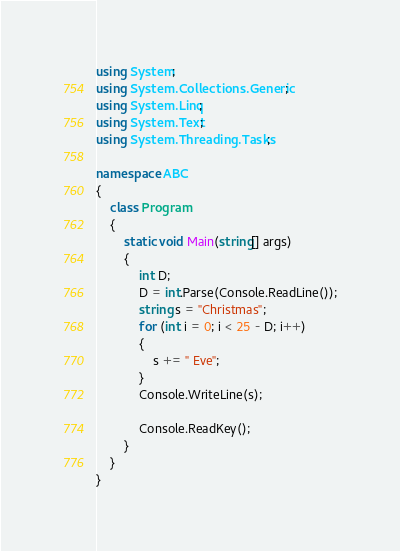<code> <loc_0><loc_0><loc_500><loc_500><_C#_>using System;
using System.Collections.Generic;
using System.Linq;
using System.Text;
using System.Threading.Tasks;

namespace ABC
{
	class Program
	{
		static void Main(string[] args)
		{
			int D;
			D = int.Parse(Console.ReadLine());
			string s = "Christmas";
			for (int i = 0; i < 25 - D; i++)
			{
				s += " Eve";
			}
			Console.WriteLine(s);

			Console.ReadKey();
		}
	}
}
</code> 